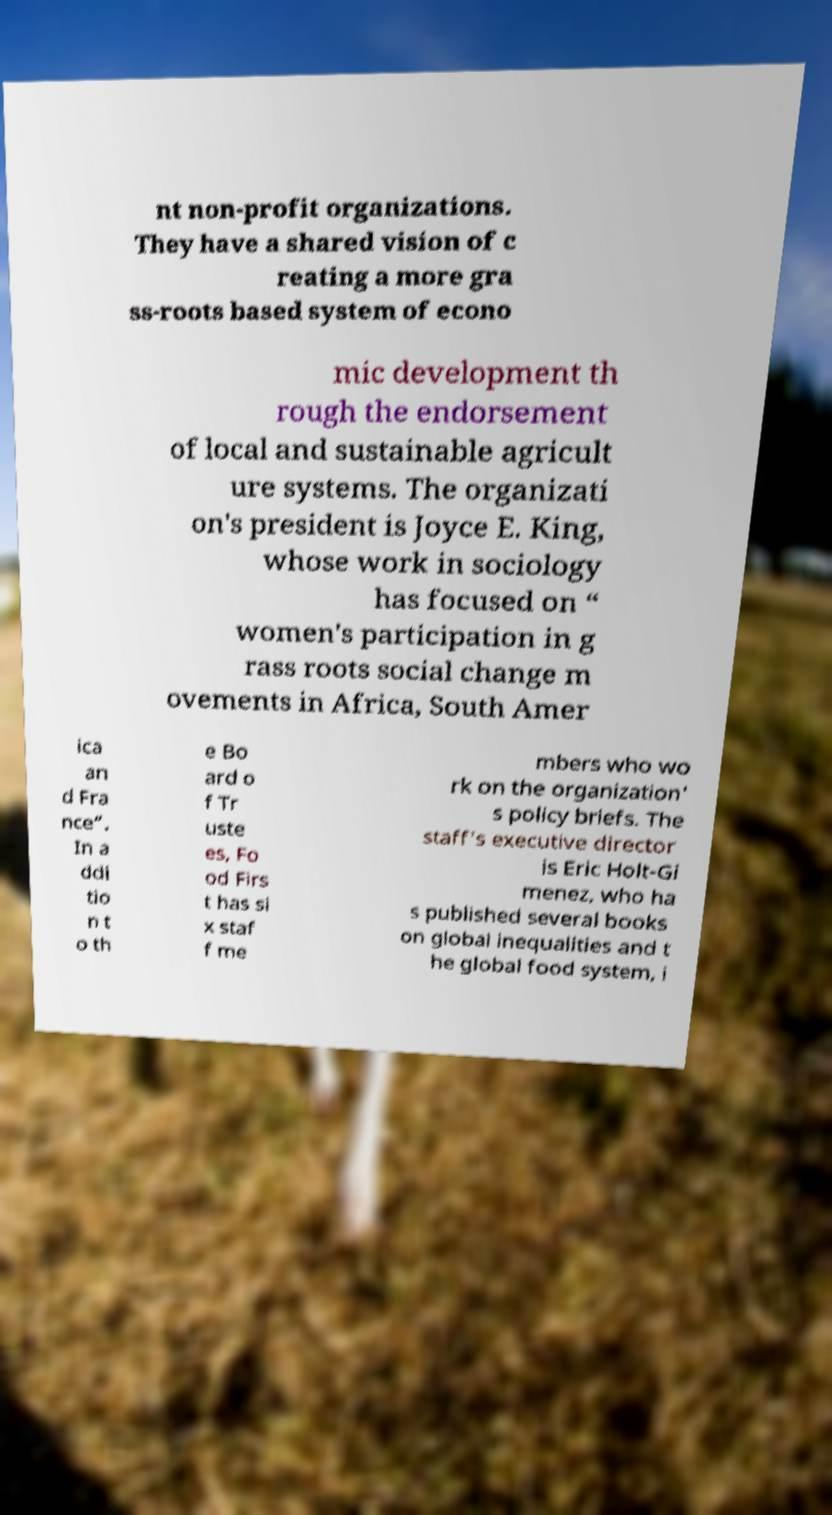There's text embedded in this image that I need extracted. Can you transcribe it verbatim? nt non-profit organizations. They have a shared vision of c reating a more gra ss-roots based system of econo mic development th rough the endorsement of local and sustainable agricult ure systems. The organizati on's president is Joyce E. King, whose work in sociology has focused on “ women's participation in g rass roots social change m ovements in Africa, South Amer ica an d Fra nce”. In a ddi tio n t o th e Bo ard o f Tr uste es, Fo od Firs t has si x staf f me mbers who wo rk on the organization' s policy briefs. The staff's executive director is Eric Holt-Gi menez, who ha s published several books on global inequalities and t he global food system, i 